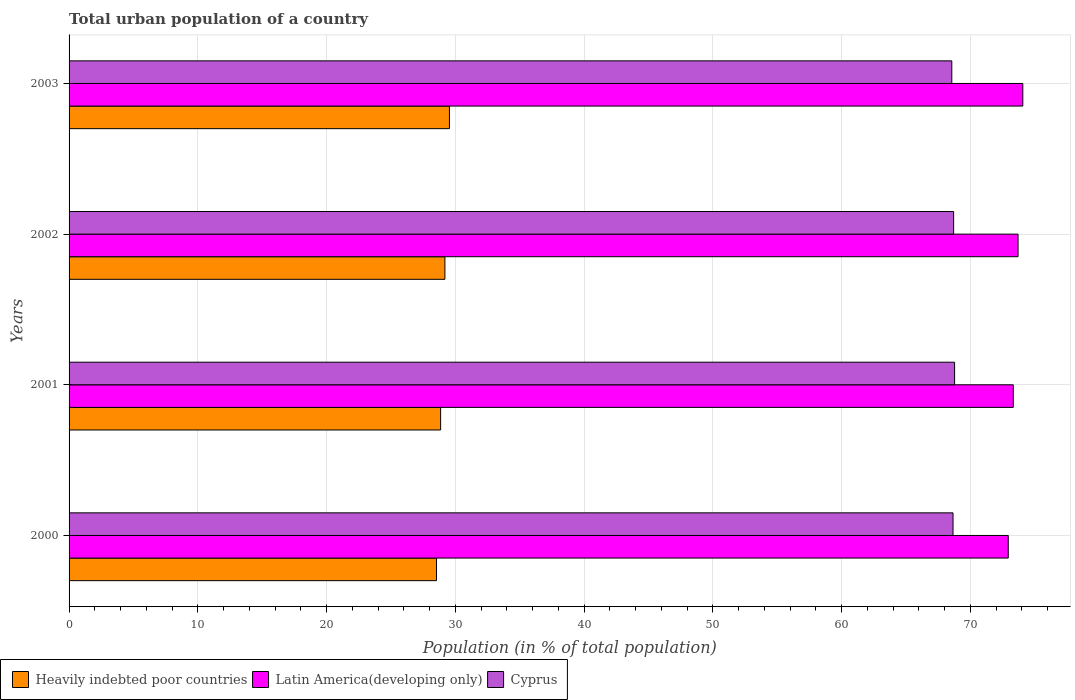How many different coloured bars are there?
Your answer should be compact. 3. Are the number of bars per tick equal to the number of legend labels?
Provide a short and direct response. Yes. Are the number of bars on each tick of the Y-axis equal?
Offer a terse response. Yes. What is the urban population in Cyprus in 2001?
Provide a short and direct response. 68.77. Across all years, what is the maximum urban population in Cyprus?
Offer a very short reply. 68.77. Across all years, what is the minimum urban population in Heavily indebted poor countries?
Provide a succinct answer. 28.53. In which year was the urban population in Latin America(developing only) maximum?
Give a very brief answer. 2003. In which year was the urban population in Latin America(developing only) minimum?
Give a very brief answer. 2000. What is the total urban population in Heavily indebted poor countries in the graph?
Offer a terse response. 116.12. What is the difference between the urban population in Cyprus in 2000 and that in 2003?
Your answer should be very brief. 0.09. What is the difference between the urban population in Heavily indebted poor countries in 2000 and the urban population in Latin America(developing only) in 2002?
Your answer should be compact. -45.17. What is the average urban population in Latin America(developing only) per year?
Make the answer very short. 73.51. In the year 2002, what is the difference between the urban population in Latin America(developing only) and urban population in Heavily indebted poor countries?
Provide a short and direct response. 44.51. In how many years, is the urban population in Cyprus greater than 4 %?
Provide a short and direct response. 4. What is the ratio of the urban population in Latin America(developing only) in 2000 to that in 2003?
Make the answer very short. 0.98. Is the difference between the urban population in Latin America(developing only) in 2002 and 2003 greater than the difference between the urban population in Heavily indebted poor countries in 2002 and 2003?
Keep it short and to the point. No. What is the difference between the highest and the second highest urban population in Heavily indebted poor countries?
Give a very brief answer. 0.35. What is the difference between the highest and the lowest urban population in Cyprus?
Offer a terse response. 0.22. What does the 2nd bar from the top in 2001 represents?
Provide a succinct answer. Latin America(developing only). What does the 1st bar from the bottom in 2002 represents?
Ensure brevity in your answer.  Heavily indebted poor countries. Is it the case that in every year, the sum of the urban population in Latin America(developing only) and urban population in Cyprus is greater than the urban population in Heavily indebted poor countries?
Your answer should be compact. Yes. How many bars are there?
Offer a very short reply. 12. Are all the bars in the graph horizontal?
Keep it short and to the point. Yes. What is the difference between two consecutive major ticks on the X-axis?
Offer a terse response. 10. Where does the legend appear in the graph?
Your response must be concise. Bottom left. How are the legend labels stacked?
Keep it short and to the point. Horizontal. What is the title of the graph?
Keep it short and to the point. Total urban population of a country. Does "Equatorial Guinea" appear as one of the legend labels in the graph?
Make the answer very short. No. What is the label or title of the X-axis?
Your answer should be very brief. Population (in % of total population). What is the Population (in % of total population) in Heavily indebted poor countries in 2000?
Provide a succinct answer. 28.53. What is the Population (in % of total population) in Latin America(developing only) in 2000?
Ensure brevity in your answer.  72.94. What is the Population (in % of total population) of Cyprus in 2000?
Give a very brief answer. 68.65. What is the Population (in % of total population) in Heavily indebted poor countries in 2001?
Ensure brevity in your answer.  28.86. What is the Population (in % of total population) of Latin America(developing only) in 2001?
Your answer should be very brief. 73.33. What is the Population (in % of total population) in Cyprus in 2001?
Offer a very short reply. 68.77. What is the Population (in % of total population) of Heavily indebted poor countries in 2002?
Offer a very short reply. 29.19. What is the Population (in % of total population) in Latin America(developing only) in 2002?
Your response must be concise. 73.7. What is the Population (in % of total population) of Cyprus in 2002?
Make the answer very short. 68.69. What is the Population (in % of total population) in Heavily indebted poor countries in 2003?
Make the answer very short. 29.54. What is the Population (in % of total population) of Latin America(developing only) in 2003?
Offer a terse response. 74.07. What is the Population (in % of total population) in Cyprus in 2003?
Ensure brevity in your answer.  68.55. Across all years, what is the maximum Population (in % of total population) of Heavily indebted poor countries?
Your answer should be compact. 29.54. Across all years, what is the maximum Population (in % of total population) in Latin America(developing only)?
Provide a short and direct response. 74.07. Across all years, what is the maximum Population (in % of total population) of Cyprus?
Offer a very short reply. 68.77. Across all years, what is the minimum Population (in % of total population) in Heavily indebted poor countries?
Provide a succinct answer. 28.53. Across all years, what is the minimum Population (in % of total population) in Latin America(developing only)?
Keep it short and to the point. 72.94. Across all years, what is the minimum Population (in % of total population) of Cyprus?
Your response must be concise. 68.55. What is the total Population (in % of total population) in Heavily indebted poor countries in the graph?
Your response must be concise. 116.12. What is the total Population (in % of total population) in Latin America(developing only) in the graph?
Make the answer very short. 294.03. What is the total Population (in % of total population) of Cyprus in the graph?
Provide a short and direct response. 274.66. What is the difference between the Population (in % of total population) of Heavily indebted poor countries in 2000 and that in 2001?
Offer a very short reply. -0.32. What is the difference between the Population (in % of total population) of Latin America(developing only) in 2000 and that in 2001?
Provide a short and direct response. -0.39. What is the difference between the Population (in % of total population) in Cyprus in 2000 and that in 2001?
Make the answer very short. -0.12. What is the difference between the Population (in % of total population) of Heavily indebted poor countries in 2000 and that in 2002?
Give a very brief answer. -0.65. What is the difference between the Population (in % of total population) in Latin America(developing only) in 2000 and that in 2002?
Provide a short and direct response. -0.76. What is the difference between the Population (in % of total population) in Cyprus in 2000 and that in 2002?
Ensure brevity in your answer.  -0.05. What is the difference between the Population (in % of total population) of Heavily indebted poor countries in 2000 and that in 2003?
Your response must be concise. -1.01. What is the difference between the Population (in % of total population) of Latin America(developing only) in 2000 and that in 2003?
Give a very brief answer. -1.13. What is the difference between the Population (in % of total population) in Cyprus in 2000 and that in 2003?
Ensure brevity in your answer.  0.1. What is the difference between the Population (in % of total population) of Heavily indebted poor countries in 2001 and that in 2002?
Your answer should be very brief. -0.33. What is the difference between the Population (in % of total population) in Latin America(developing only) in 2001 and that in 2002?
Keep it short and to the point. -0.37. What is the difference between the Population (in % of total population) of Cyprus in 2001 and that in 2002?
Your answer should be very brief. 0.07. What is the difference between the Population (in % of total population) of Heavily indebted poor countries in 2001 and that in 2003?
Offer a very short reply. -0.68. What is the difference between the Population (in % of total population) of Latin America(developing only) in 2001 and that in 2003?
Your response must be concise. -0.74. What is the difference between the Population (in % of total population) of Cyprus in 2001 and that in 2003?
Offer a terse response. 0.22. What is the difference between the Population (in % of total population) in Heavily indebted poor countries in 2002 and that in 2003?
Give a very brief answer. -0.35. What is the difference between the Population (in % of total population) in Latin America(developing only) in 2002 and that in 2003?
Keep it short and to the point. -0.37. What is the difference between the Population (in % of total population) in Cyprus in 2002 and that in 2003?
Give a very brief answer. 0.14. What is the difference between the Population (in % of total population) in Heavily indebted poor countries in 2000 and the Population (in % of total population) in Latin America(developing only) in 2001?
Offer a very short reply. -44.79. What is the difference between the Population (in % of total population) of Heavily indebted poor countries in 2000 and the Population (in % of total population) of Cyprus in 2001?
Give a very brief answer. -40.24. What is the difference between the Population (in % of total population) in Latin America(developing only) in 2000 and the Population (in % of total population) in Cyprus in 2001?
Provide a succinct answer. 4.17. What is the difference between the Population (in % of total population) in Heavily indebted poor countries in 2000 and the Population (in % of total population) in Latin America(developing only) in 2002?
Make the answer very short. -45.17. What is the difference between the Population (in % of total population) in Heavily indebted poor countries in 2000 and the Population (in % of total population) in Cyprus in 2002?
Your answer should be very brief. -40.16. What is the difference between the Population (in % of total population) in Latin America(developing only) in 2000 and the Population (in % of total population) in Cyprus in 2002?
Keep it short and to the point. 4.24. What is the difference between the Population (in % of total population) of Heavily indebted poor countries in 2000 and the Population (in % of total population) of Latin America(developing only) in 2003?
Ensure brevity in your answer.  -45.53. What is the difference between the Population (in % of total population) of Heavily indebted poor countries in 2000 and the Population (in % of total population) of Cyprus in 2003?
Keep it short and to the point. -40.02. What is the difference between the Population (in % of total population) in Latin America(developing only) in 2000 and the Population (in % of total population) in Cyprus in 2003?
Your response must be concise. 4.39. What is the difference between the Population (in % of total population) of Heavily indebted poor countries in 2001 and the Population (in % of total population) of Latin America(developing only) in 2002?
Your answer should be very brief. -44.84. What is the difference between the Population (in % of total population) in Heavily indebted poor countries in 2001 and the Population (in % of total population) in Cyprus in 2002?
Offer a terse response. -39.84. What is the difference between the Population (in % of total population) in Latin America(developing only) in 2001 and the Population (in % of total population) in Cyprus in 2002?
Give a very brief answer. 4.63. What is the difference between the Population (in % of total population) in Heavily indebted poor countries in 2001 and the Population (in % of total population) in Latin America(developing only) in 2003?
Ensure brevity in your answer.  -45.21. What is the difference between the Population (in % of total population) in Heavily indebted poor countries in 2001 and the Population (in % of total population) in Cyprus in 2003?
Your answer should be compact. -39.7. What is the difference between the Population (in % of total population) of Latin America(developing only) in 2001 and the Population (in % of total population) of Cyprus in 2003?
Ensure brevity in your answer.  4.77. What is the difference between the Population (in % of total population) of Heavily indebted poor countries in 2002 and the Population (in % of total population) of Latin America(developing only) in 2003?
Your response must be concise. -44.88. What is the difference between the Population (in % of total population) of Heavily indebted poor countries in 2002 and the Population (in % of total population) of Cyprus in 2003?
Keep it short and to the point. -39.37. What is the difference between the Population (in % of total population) in Latin America(developing only) in 2002 and the Population (in % of total population) in Cyprus in 2003?
Offer a very short reply. 5.15. What is the average Population (in % of total population) of Heavily indebted poor countries per year?
Make the answer very short. 29.03. What is the average Population (in % of total population) of Latin America(developing only) per year?
Your response must be concise. 73.51. What is the average Population (in % of total population) in Cyprus per year?
Ensure brevity in your answer.  68.67. In the year 2000, what is the difference between the Population (in % of total population) of Heavily indebted poor countries and Population (in % of total population) of Latin America(developing only)?
Make the answer very short. -44.4. In the year 2000, what is the difference between the Population (in % of total population) in Heavily indebted poor countries and Population (in % of total population) in Cyprus?
Keep it short and to the point. -40.11. In the year 2000, what is the difference between the Population (in % of total population) in Latin America(developing only) and Population (in % of total population) in Cyprus?
Provide a succinct answer. 4.29. In the year 2001, what is the difference between the Population (in % of total population) of Heavily indebted poor countries and Population (in % of total population) of Latin America(developing only)?
Ensure brevity in your answer.  -44.47. In the year 2001, what is the difference between the Population (in % of total population) in Heavily indebted poor countries and Population (in % of total population) in Cyprus?
Ensure brevity in your answer.  -39.91. In the year 2001, what is the difference between the Population (in % of total population) of Latin America(developing only) and Population (in % of total population) of Cyprus?
Offer a very short reply. 4.56. In the year 2002, what is the difference between the Population (in % of total population) of Heavily indebted poor countries and Population (in % of total population) of Latin America(developing only)?
Make the answer very short. -44.51. In the year 2002, what is the difference between the Population (in % of total population) of Heavily indebted poor countries and Population (in % of total population) of Cyprus?
Provide a short and direct response. -39.51. In the year 2002, what is the difference between the Population (in % of total population) in Latin America(developing only) and Population (in % of total population) in Cyprus?
Make the answer very short. 5. In the year 2003, what is the difference between the Population (in % of total population) in Heavily indebted poor countries and Population (in % of total population) in Latin America(developing only)?
Your answer should be compact. -44.53. In the year 2003, what is the difference between the Population (in % of total population) of Heavily indebted poor countries and Population (in % of total population) of Cyprus?
Provide a short and direct response. -39.01. In the year 2003, what is the difference between the Population (in % of total population) in Latin America(developing only) and Population (in % of total population) in Cyprus?
Your answer should be compact. 5.51. What is the ratio of the Population (in % of total population) of Heavily indebted poor countries in 2000 to that in 2001?
Keep it short and to the point. 0.99. What is the ratio of the Population (in % of total population) in Latin America(developing only) in 2000 to that in 2001?
Your answer should be compact. 0.99. What is the ratio of the Population (in % of total population) in Heavily indebted poor countries in 2000 to that in 2002?
Your answer should be compact. 0.98. What is the ratio of the Population (in % of total population) in Cyprus in 2000 to that in 2002?
Provide a short and direct response. 1. What is the ratio of the Population (in % of total population) of Heavily indebted poor countries in 2000 to that in 2003?
Provide a short and direct response. 0.97. What is the ratio of the Population (in % of total population) in Latin America(developing only) in 2000 to that in 2003?
Provide a short and direct response. 0.98. What is the ratio of the Population (in % of total population) of Heavily indebted poor countries in 2001 to that in 2002?
Your answer should be compact. 0.99. What is the ratio of the Population (in % of total population) in Latin America(developing only) in 2001 to that in 2002?
Offer a very short reply. 0.99. What is the ratio of the Population (in % of total population) in Heavily indebted poor countries in 2001 to that in 2003?
Offer a very short reply. 0.98. What is the ratio of the Population (in % of total population) in Latin America(developing only) in 2001 to that in 2003?
Offer a terse response. 0.99. What is the ratio of the Population (in % of total population) in Latin America(developing only) in 2002 to that in 2003?
Give a very brief answer. 0.99. What is the difference between the highest and the second highest Population (in % of total population) in Heavily indebted poor countries?
Make the answer very short. 0.35. What is the difference between the highest and the second highest Population (in % of total population) of Latin America(developing only)?
Your response must be concise. 0.37. What is the difference between the highest and the second highest Population (in % of total population) of Cyprus?
Ensure brevity in your answer.  0.07. What is the difference between the highest and the lowest Population (in % of total population) in Latin America(developing only)?
Keep it short and to the point. 1.13. What is the difference between the highest and the lowest Population (in % of total population) in Cyprus?
Your answer should be very brief. 0.22. 